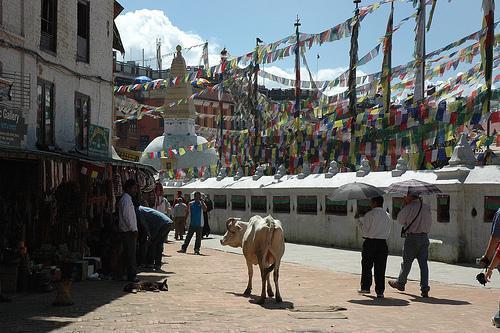How many cows are there?
Give a very brief answer. 1. How many people are holding umbrellas?
Give a very brief answer. 2. 